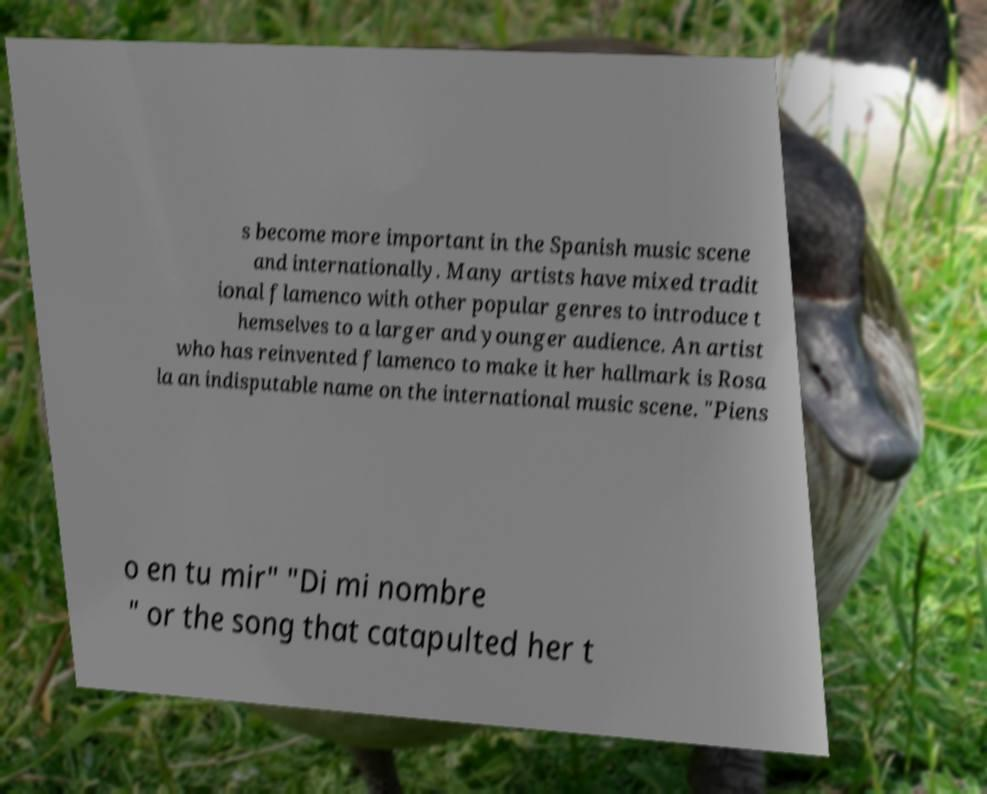Please identify and transcribe the text found in this image. s become more important in the Spanish music scene and internationally. Many artists have mixed tradit ional flamenco with other popular genres to introduce t hemselves to a larger and younger audience. An artist who has reinvented flamenco to make it her hallmark is Rosa la an indisputable name on the international music scene. "Piens o en tu mir" "Di mi nombre " or the song that catapulted her t 